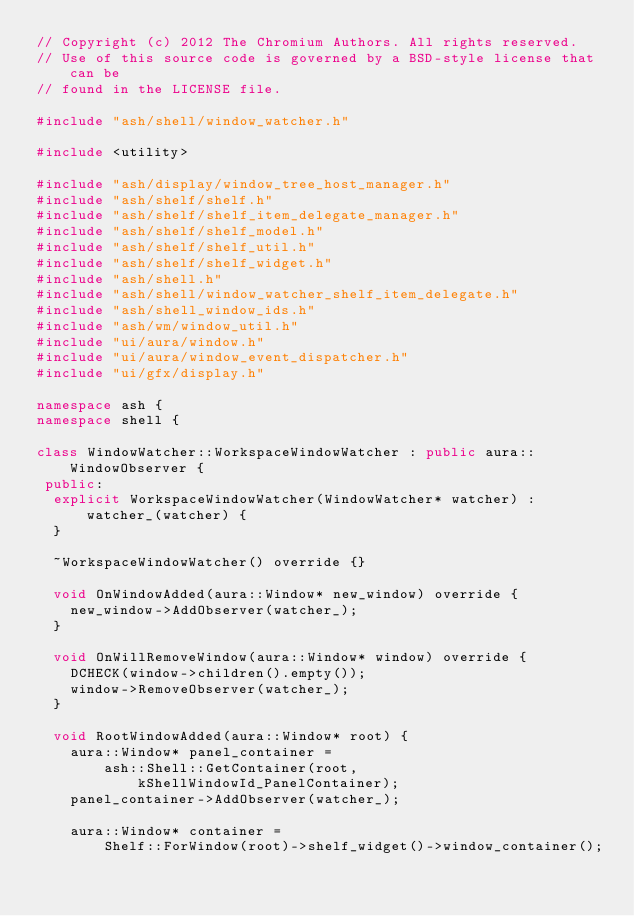Convert code to text. <code><loc_0><loc_0><loc_500><loc_500><_C++_>// Copyright (c) 2012 The Chromium Authors. All rights reserved.
// Use of this source code is governed by a BSD-style license that can be
// found in the LICENSE file.

#include "ash/shell/window_watcher.h"

#include <utility>

#include "ash/display/window_tree_host_manager.h"
#include "ash/shelf/shelf.h"
#include "ash/shelf/shelf_item_delegate_manager.h"
#include "ash/shelf/shelf_model.h"
#include "ash/shelf/shelf_util.h"
#include "ash/shelf/shelf_widget.h"
#include "ash/shell.h"
#include "ash/shell/window_watcher_shelf_item_delegate.h"
#include "ash/shell_window_ids.h"
#include "ash/wm/window_util.h"
#include "ui/aura/window.h"
#include "ui/aura/window_event_dispatcher.h"
#include "ui/gfx/display.h"

namespace ash {
namespace shell {

class WindowWatcher::WorkspaceWindowWatcher : public aura::WindowObserver {
 public:
  explicit WorkspaceWindowWatcher(WindowWatcher* watcher) : watcher_(watcher) {
  }

  ~WorkspaceWindowWatcher() override {}

  void OnWindowAdded(aura::Window* new_window) override {
    new_window->AddObserver(watcher_);
  }

  void OnWillRemoveWindow(aura::Window* window) override {
    DCHECK(window->children().empty());
    window->RemoveObserver(watcher_);
  }

  void RootWindowAdded(aura::Window* root) {
    aura::Window* panel_container =
        ash::Shell::GetContainer(root, kShellWindowId_PanelContainer);
    panel_container->AddObserver(watcher_);

    aura::Window* container =
        Shelf::ForWindow(root)->shelf_widget()->window_container();</code> 